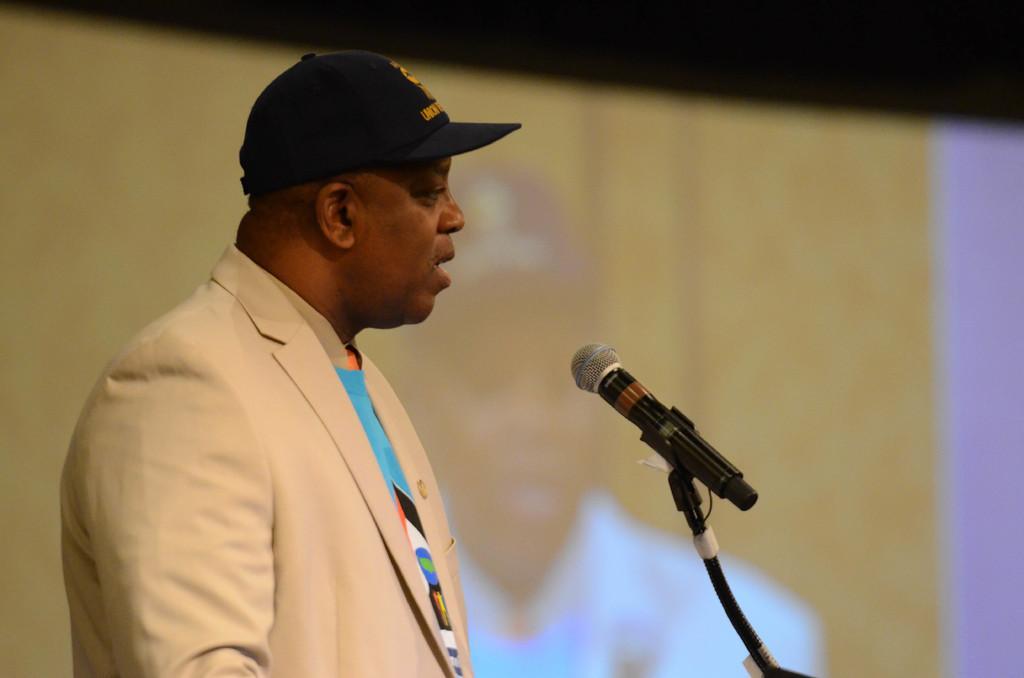Describe this image in one or two sentences. As we can see in the image, there is a man wearing cap, cream color suit and talking on mike. 